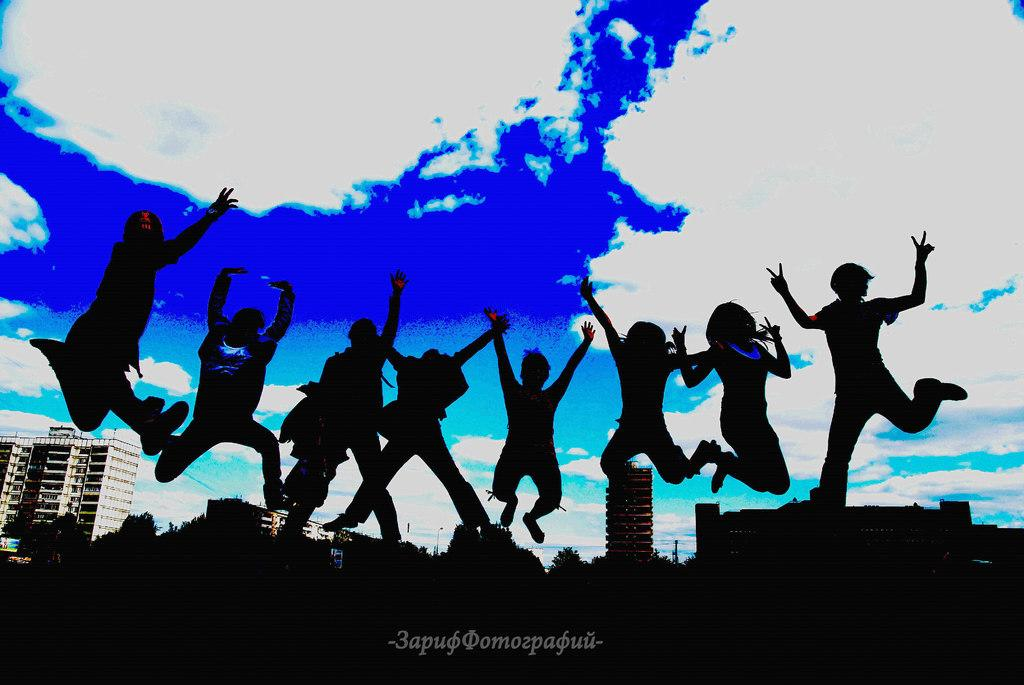Who or what is present in the image? There are people in the image. What are the people doing in the image? The people are jumping. What else can be seen in the image besides the people? Their shadows are visible, and there are buildings in the background of the image. How would you describe the weather in the image? The sky is clear, suggesting good weather. Where is the stream located in the image? There is no stream present in the image. What color is the heart of the person jumping in the image? It is not possible to determine the color of a person's heart from the image, as hearts are not visible externally. 